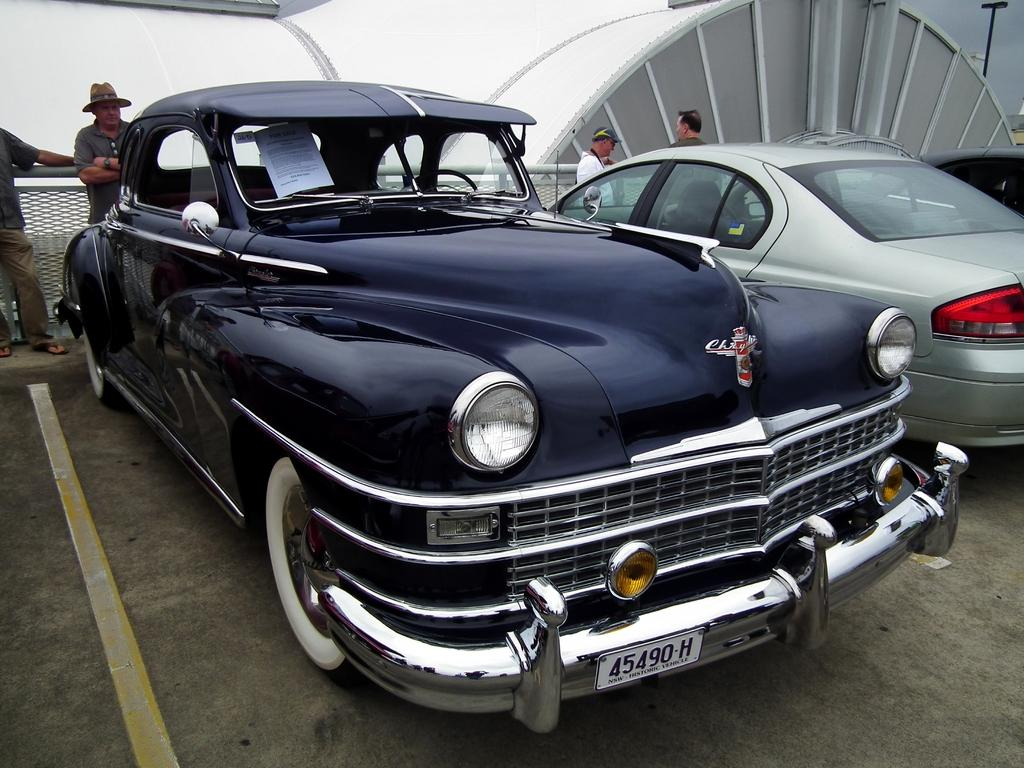How many cars are parked in the parking lot in the image? There are two cars parked in the parking lot in the image. What is the location of the cars in relation to the building? The cars are in front of a building. Are there any people visible in the image? Yes, there are people standing behind the cars. What type of rings can be seen on the tires of the cars in the image? There are no rings visible on the tires of the cars in the image. Is there any dirt visible on the cars in the image? The provided facts do not mention any dirt on the cars, so we cannot determine if there is any dirt visible. 